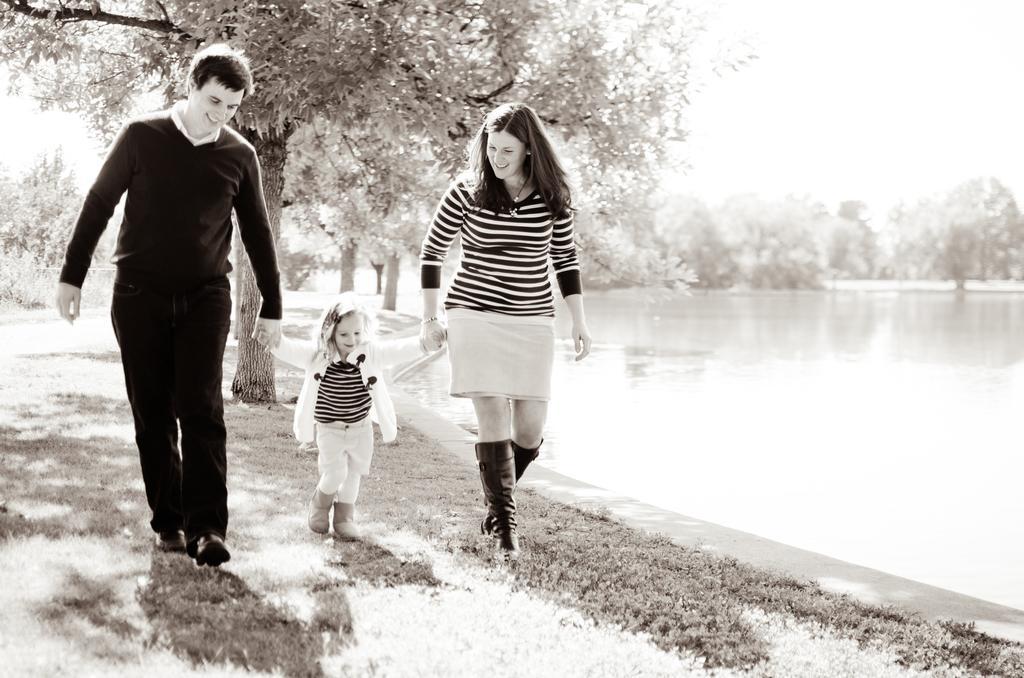Could you give a brief overview of what you see in this image? In the picture I can see a man, a woman and a girl are walking on the ground. In the background I can see trees, water and the sky. This image is black and white in color. 